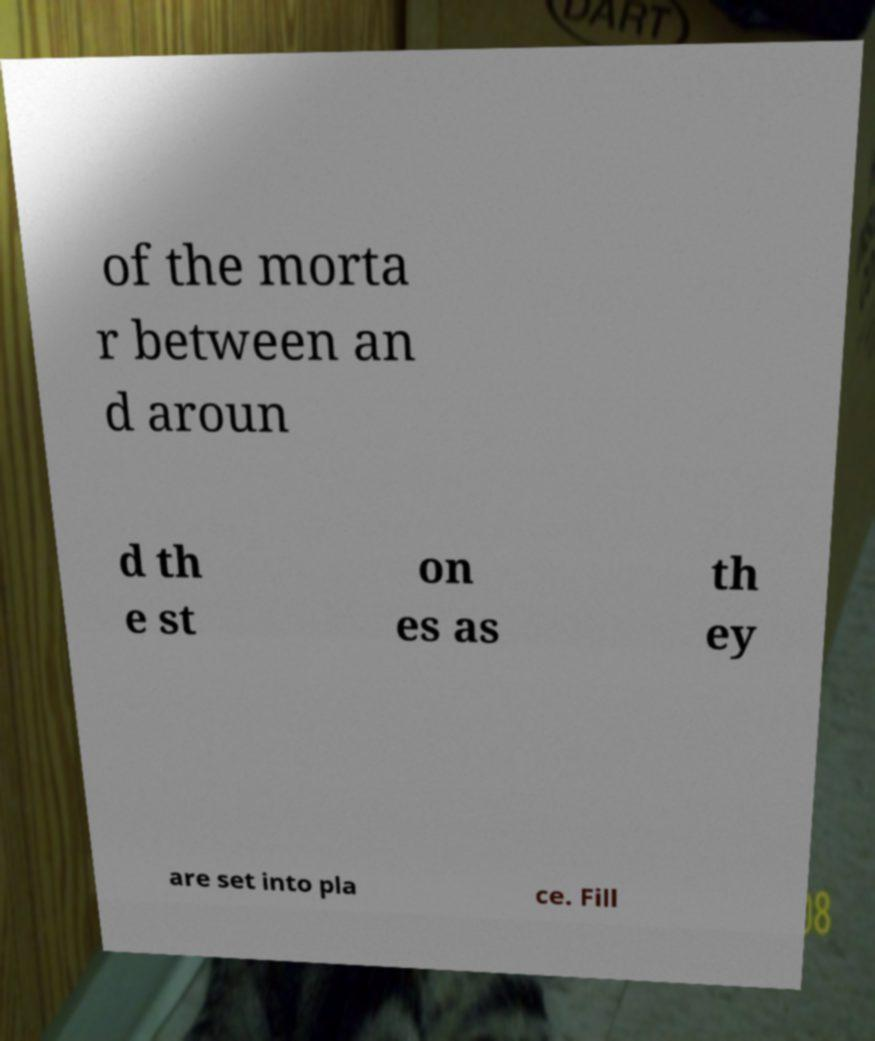There's text embedded in this image that I need extracted. Can you transcribe it verbatim? of the morta r between an d aroun d th e st on es as th ey are set into pla ce. Fill 